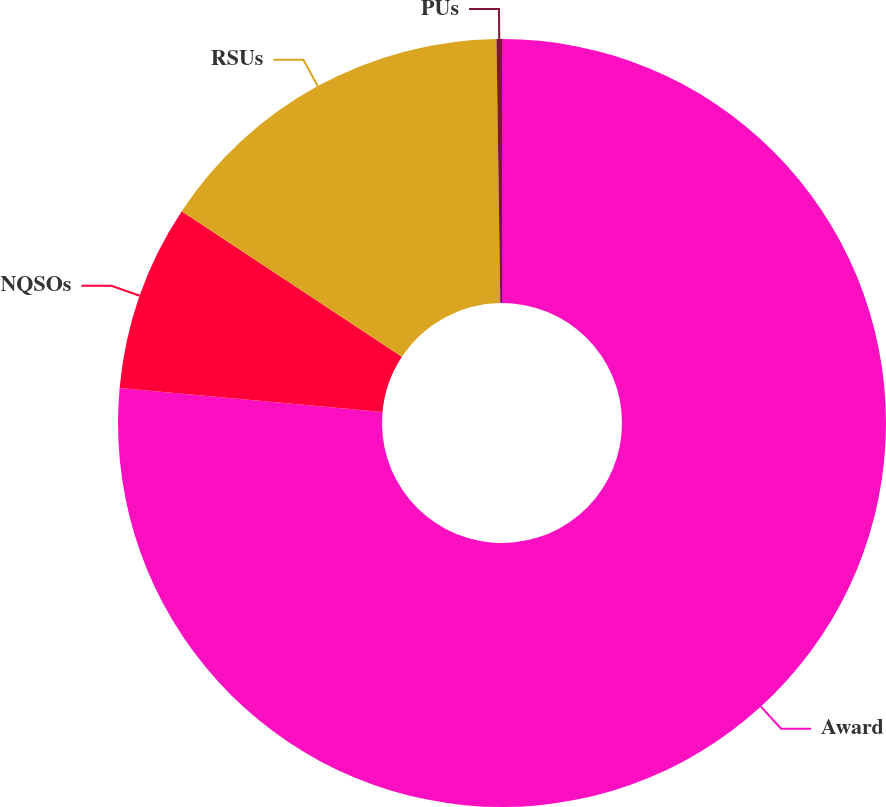Convert chart to OTSL. <chart><loc_0><loc_0><loc_500><loc_500><pie_chart><fcel>Award<fcel>NQSOs<fcel>RSUs<fcel>PUs<nl><fcel>76.45%<fcel>7.85%<fcel>15.47%<fcel>0.23%<nl></chart> 